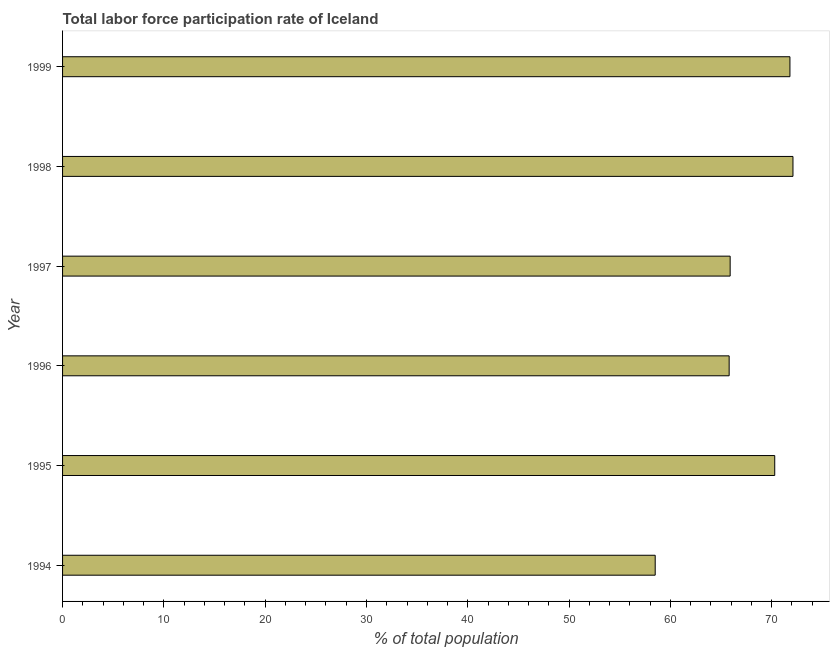Does the graph contain any zero values?
Offer a terse response. No. What is the title of the graph?
Ensure brevity in your answer.  Total labor force participation rate of Iceland. What is the label or title of the X-axis?
Give a very brief answer. % of total population. What is the total labor force participation rate in 1995?
Your answer should be very brief. 70.3. Across all years, what is the maximum total labor force participation rate?
Your answer should be very brief. 72.1. Across all years, what is the minimum total labor force participation rate?
Your answer should be very brief. 58.5. What is the sum of the total labor force participation rate?
Your response must be concise. 404.4. What is the average total labor force participation rate per year?
Ensure brevity in your answer.  67.4. What is the median total labor force participation rate?
Your answer should be compact. 68.1. Do a majority of the years between 1999 and 1998 (inclusive) have total labor force participation rate greater than 64 %?
Your response must be concise. No. What is the ratio of the total labor force participation rate in 1996 to that in 1999?
Your answer should be very brief. 0.92. Is the total labor force participation rate in 1998 less than that in 1999?
Offer a very short reply. No. What is the difference between the highest and the second highest total labor force participation rate?
Offer a very short reply. 0.3. What is the difference between the highest and the lowest total labor force participation rate?
Your answer should be very brief. 13.6. Are all the bars in the graph horizontal?
Your answer should be compact. Yes. How many years are there in the graph?
Your answer should be compact. 6. What is the % of total population of 1994?
Keep it short and to the point. 58.5. What is the % of total population in 1995?
Your response must be concise. 70.3. What is the % of total population of 1996?
Your answer should be compact. 65.8. What is the % of total population in 1997?
Make the answer very short. 65.9. What is the % of total population in 1998?
Make the answer very short. 72.1. What is the % of total population of 1999?
Your answer should be very brief. 71.8. What is the difference between the % of total population in 1994 and 1996?
Offer a terse response. -7.3. What is the difference between the % of total population in 1994 and 1997?
Provide a succinct answer. -7.4. What is the difference between the % of total population in 1994 and 1998?
Ensure brevity in your answer.  -13.6. What is the difference between the % of total population in 1994 and 1999?
Make the answer very short. -13.3. What is the difference between the % of total population in 1995 and 1996?
Offer a terse response. 4.5. What is the difference between the % of total population in 1995 and 1997?
Provide a succinct answer. 4.4. What is the difference between the % of total population in 1995 and 1999?
Your answer should be compact. -1.5. What is the difference between the % of total population in 1997 and 1998?
Your answer should be compact. -6.2. What is the difference between the % of total population in 1997 and 1999?
Make the answer very short. -5.9. What is the ratio of the % of total population in 1994 to that in 1995?
Keep it short and to the point. 0.83. What is the ratio of the % of total population in 1994 to that in 1996?
Keep it short and to the point. 0.89. What is the ratio of the % of total population in 1994 to that in 1997?
Give a very brief answer. 0.89. What is the ratio of the % of total population in 1994 to that in 1998?
Your answer should be compact. 0.81. What is the ratio of the % of total population in 1994 to that in 1999?
Your response must be concise. 0.81. What is the ratio of the % of total population in 1995 to that in 1996?
Keep it short and to the point. 1.07. What is the ratio of the % of total population in 1995 to that in 1997?
Offer a very short reply. 1.07. What is the ratio of the % of total population in 1995 to that in 1998?
Your response must be concise. 0.97. What is the ratio of the % of total population in 1995 to that in 1999?
Keep it short and to the point. 0.98. What is the ratio of the % of total population in 1996 to that in 1997?
Keep it short and to the point. 1. What is the ratio of the % of total population in 1996 to that in 1999?
Keep it short and to the point. 0.92. What is the ratio of the % of total population in 1997 to that in 1998?
Offer a terse response. 0.91. What is the ratio of the % of total population in 1997 to that in 1999?
Offer a very short reply. 0.92. 